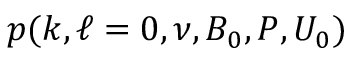<formula> <loc_0><loc_0><loc_500><loc_500>p ( k , \ell = 0 , \nu , B _ { 0 } , P , U _ { 0 } )</formula> 